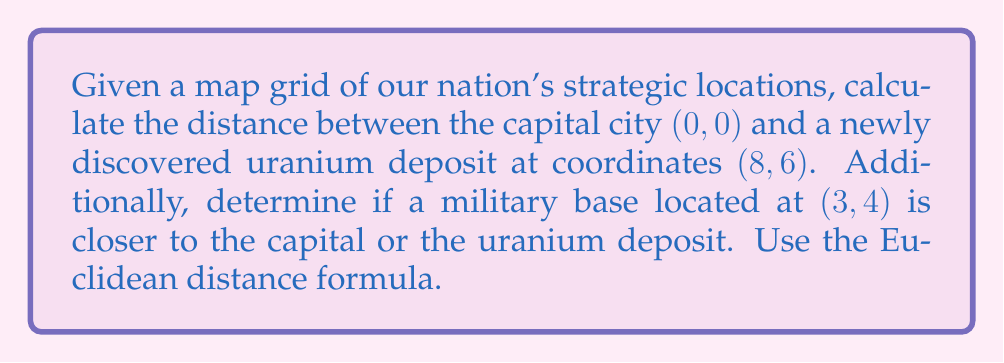Can you answer this question? To solve this problem, we'll use the Euclidean distance formula:

$$d = \sqrt{(x_2 - x_1)^2 + (y_2 - y_1)^2}$$

1. Distance between the capital (0, 0) and uranium deposit (8, 6):
   $$d_{cu} = \sqrt{(8 - 0)^2 + (6 - 0)^2} = \sqrt{64 + 36} = \sqrt{100} = 10$$

2. Distance between the capital (0, 0) and military base (3, 4):
   $$d_{cm} = \sqrt{(3 - 0)^2 + (4 - 0)^2} = \sqrt{9 + 16} = \sqrt{25} = 5$$

3. Distance between the military base (3, 4) and uranium deposit (8, 6):
   $$d_{mu} = \sqrt{(8 - 3)^2 + (6 - 4)^2} = \sqrt{25 + 4} = \sqrt{29} \approx 5.39$$

Comparing the distances:
$d_{cm} = 5 < d_{mu} \approx 5.39$

Therefore, the military base is closer to the capital than to the uranium deposit.
Answer: The distance between the capital and uranium deposit is 10 units. The military base is closer to the capital, being 5 units away from the capital and approximately 5.39 units away from the uranium deposit. 